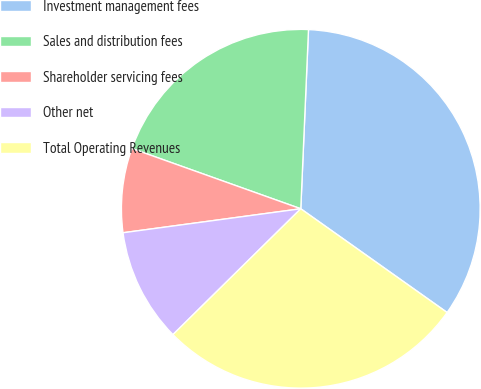<chart> <loc_0><loc_0><loc_500><loc_500><pie_chart><fcel>Investment management fees<fcel>Sales and distribution fees<fcel>Shareholder servicing fees<fcel>Other net<fcel>Total Operating Revenues<nl><fcel>34.13%<fcel>20.23%<fcel>7.59%<fcel>10.24%<fcel>27.81%<nl></chart> 